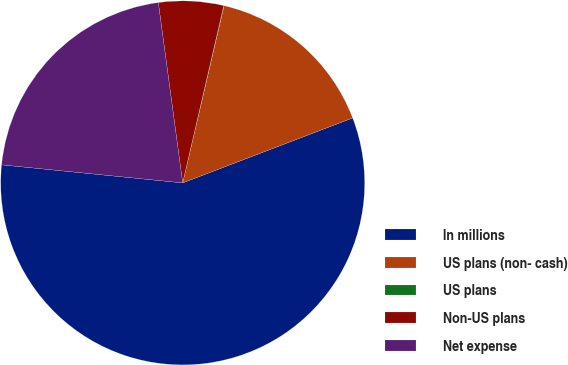<chart> <loc_0><loc_0><loc_500><loc_500><pie_chart><fcel>In millions<fcel>US plans (non- cash)<fcel>US plans<fcel>Non-US plans<fcel>Net expense<nl><fcel>57.39%<fcel>15.54%<fcel>0.03%<fcel>5.76%<fcel>21.28%<nl></chart> 